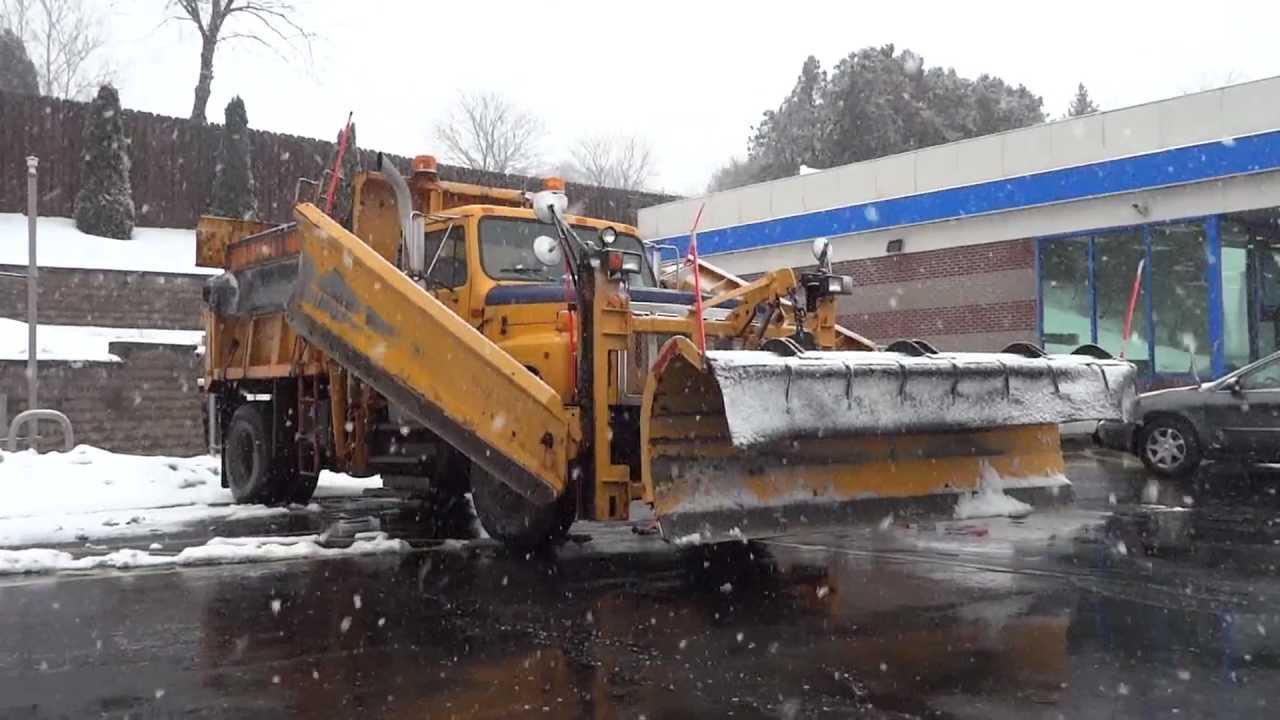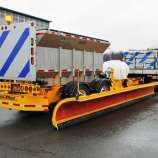The first image is the image on the left, the second image is the image on the right. Evaluate the accuracy of this statement regarding the images: "A bulldozers front panel is partially lifted off the ground.". Is it true? Answer yes or no. Yes. 